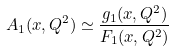Convert formula to latex. <formula><loc_0><loc_0><loc_500><loc_500>A _ { 1 } ( x , Q ^ { 2 } ) \simeq \frac { g _ { 1 } ( x , Q ^ { 2 } ) } { F _ { 1 } ( x , Q ^ { 2 } ) }</formula> 